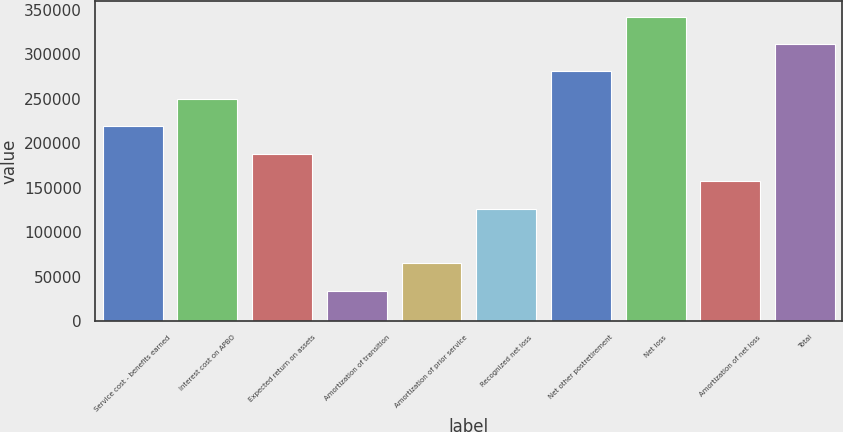Convert chart. <chart><loc_0><loc_0><loc_500><loc_500><bar_chart><fcel>Service cost - benefits earned<fcel>Interest cost on APBO<fcel>Expected return on assets<fcel>Amortization of transition<fcel>Amortization of prior service<fcel>Recognized net loss<fcel>Net other postretirement<fcel>Net loss<fcel>Amortization of net loss<fcel>Total<nl><fcel>218984<fcel>249813<fcel>188154<fcel>34006.5<fcel>64836<fcel>126495<fcel>280642<fcel>342302<fcel>157324<fcel>311472<nl></chart> 